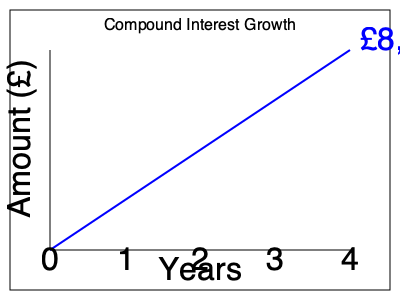As a financial reporter, you're analyzing the growth of an investment over time. The graph shows the compound interest growth of an initial investment over 4 years. If the initial investment was £5,000 and the final amount after 4 years is £8,000, what was the annual compound interest rate (rounded to the nearest whole percent)? To solve this problem, we'll use the compound interest formula:

$$A = P(1 + r)^t$$

Where:
$A$ = Final amount
$P$ = Principal (initial investment)
$r$ = Annual interest rate (in decimal form)
$t$ = Time in years

We know:
$A = £8,000$
$P = £5,000$
$t = 4$ years

Let's solve for $r$:

1) Substitute the known values into the formula:
   $$8000 = 5000(1 + r)^4$$

2) Divide both sides by 5000:
   $$1.6 = (1 + r)^4$$

3) Take the fourth root of both sides:
   $$\sqrt[4]{1.6} = 1 + r$$

4) Subtract 1 from both sides:
   $$\sqrt[4]{1.6} - 1 = r$$

5) Calculate:
   $$r \approx 0.1249$$

6) Convert to a percentage and round to the nearest whole percent:
   $$0.1249 \times 100 \approx 12.49\% \approx 12\%$$

Therefore, the annual compound interest rate is approximately 12%.
Answer: 12% 